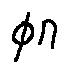<formula> <loc_0><loc_0><loc_500><loc_500>\phi n</formula> 